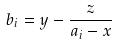Convert formula to latex. <formula><loc_0><loc_0><loc_500><loc_500>b _ { i } = y - \frac { z } { a _ { i } - x }</formula> 